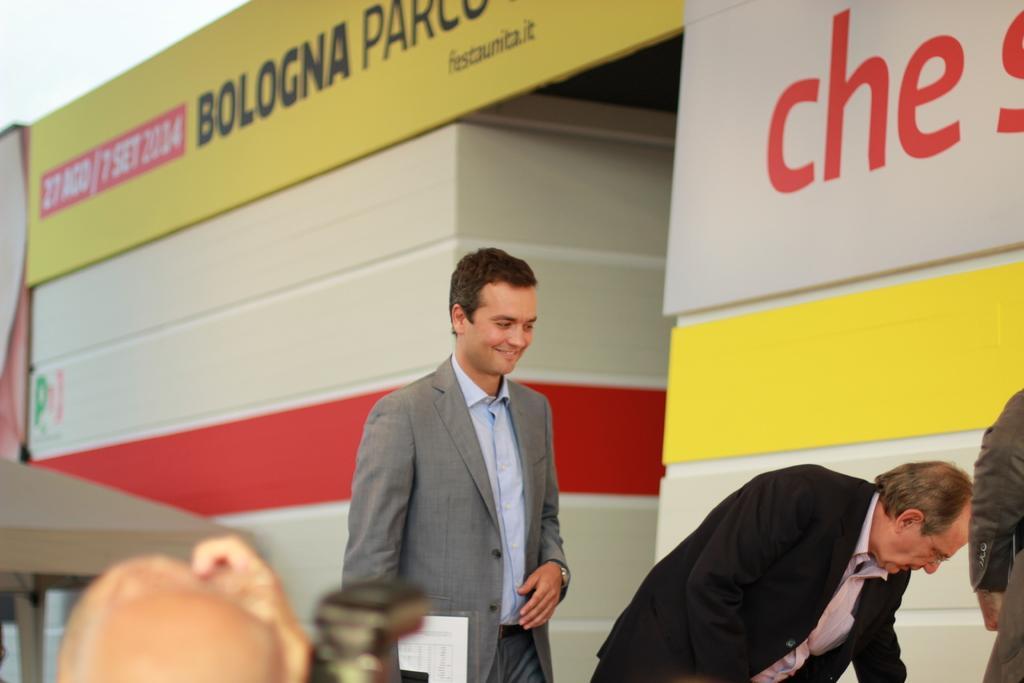Describe this image in one or two sentences. In this image I can see two men and I can see both of them are wearing formal dress. I can see smile on his face and in the background I can see something is written at few places. 